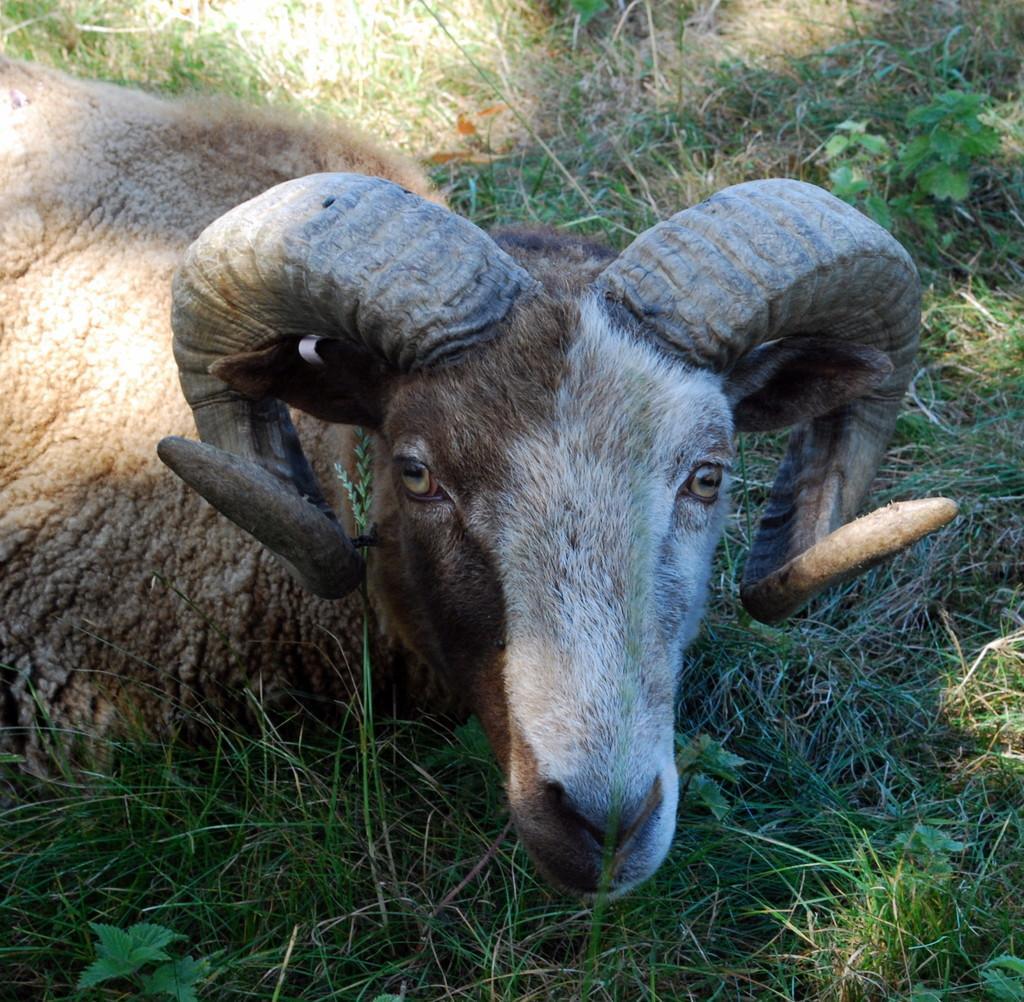Describe this image in one or two sentences. In this image there is a sheep laying on a grassland. 